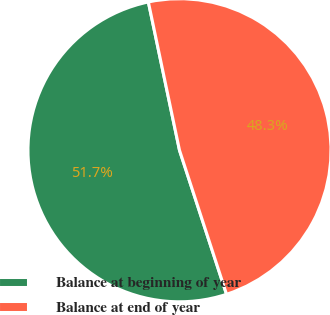Convert chart. <chart><loc_0><loc_0><loc_500><loc_500><pie_chart><fcel>Balance at beginning of year<fcel>Balance at end of year<nl><fcel>51.73%<fcel>48.27%<nl></chart> 